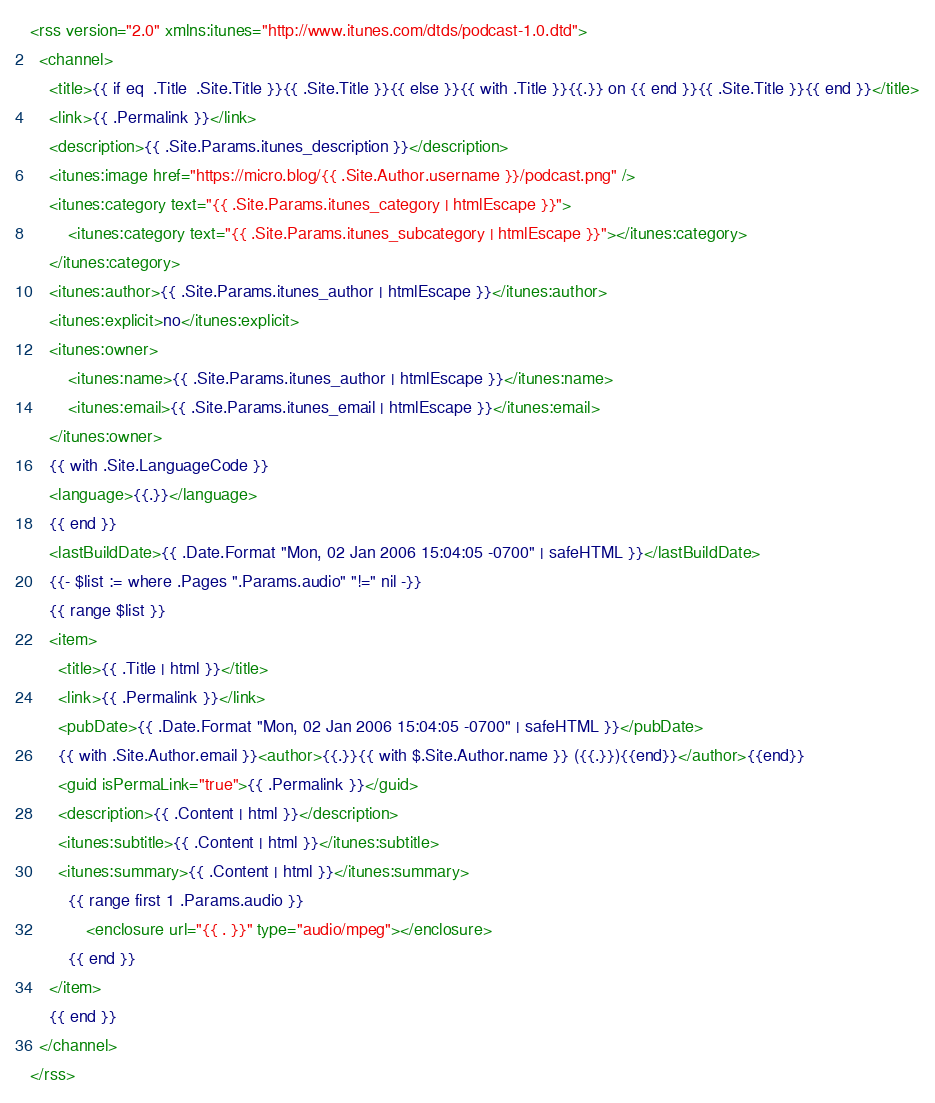Convert code to text. <code><loc_0><loc_0><loc_500><loc_500><_XML_><rss version="2.0" xmlns:itunes="http://www.itunes.com/dtds/podcast-1.0.dtd">
  <channel>
    <title>{{ if eq  .Title  .Site.Title }}{{ .Site.Title }}{{ else }}{{ with .Title }}{{.}} on {{ end }}{{ .Site.Title }}{{ end }}</title>
    <link>{{ .Permalink }}</link>
    <description>{{ .Site.Params.itunes_description }}</description>
	<itunes:image href="https://micro.blog/{{ .Site.Author.username }}/podcast.png" />
	<itunes:category text="{{ .Site.Params.itunes_category | htmlEscape }}">
		<itunes:category text="{{ .Site.Params.itunes_subcategory | htmlEscape }}"></itunes:category>
	</itunes:category>
	<itunes:author>{{ .Site.Params.itunes_author | htmlEscape }}</itunes:author>
	<itunes:explicit>no</itunes:explicit>		
	<itunes:owner>
		<itunes:name>{{ .Site.Params.itunes_author | htmlEscape }}</itunes:name>
		<itunes:email>{{ .Site.Params.itunes_email | htmlEscape }}</itunes:email>
	</itunes:owner>
    {{ with .Site.LanguageCode }}
    <language>{{.}}</language>
    {{ end }}
    <lastBuildDate>{{ .Date.Format "Mon, 02 Jan 2006 15:04:05 -0700" | safeHTML }}</lastBuildDate>
	{{- $list := where .Pages ".Params.audio" "!=" nil -}}
    {{ range $list }}
    <item>
      <title>{{ .Title | html }}</title>
      <link>{{ .Permalink }}</link>
      <pubDate>{{ .Date.Format "Mon, 02 Jan 2006 15:04:05 -0700" | safeHTML }}</pubDate>
      {{ with .Site.Author.email }}<author>{{.}}{{ with $.Site.Author.name }} ({{.}}){{end}}</author>{{end}}
      <guid isPermaLink="true">{{ .Permalink }}</guid>
      <description>{{ .Content | html }}</description>
      <itunes:subtitle>{{ .Content | html }}</itunes:subtitle>
      <itunes:summary>{{ .Content | html }}</itunes:summary>
		{{ range first 1 .Params.audio }}
			<enclosure url="{{ . }}" type="audio/mpeg"></enclosure>
		{{ end }}
    </item>
    {{ end }}
  </channel>
</rss></code> 